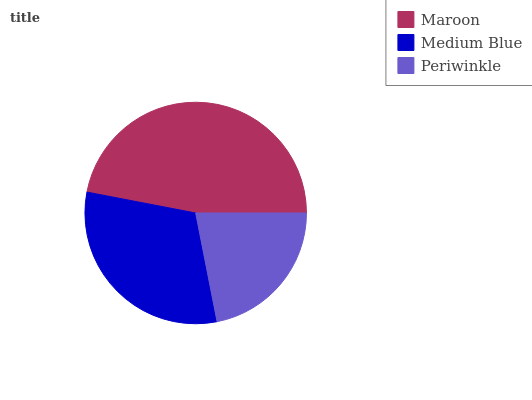Is Periwinkle the minimum?
Answer yes or no. Yes. Is Maroon the maximum?
Answer yes or no. Yes. Is Medium Blue the minimum?
Answer yes or no. No. Is Medium Blue the maximum?
Answer yes or no. No. Is Maroon greater than Medium Blue?
Answer yes or no. Yes. Is Medium Blue less than Maroon?
Answer yes or no. Yes. Is Medium Blue greater than Maroon?
Answer yes or no. No. Is Maroon less than Medium Blue?
Answer yes or no. No. Is Medium Blue the high median?
Answer yes or no. Yes. Is Medium Blue the low median?
Answer yes or no. Yes. Is Periwinkle the high median?
Answer yes or no. No. Is Periwinkle the low median?
Answer yes or no. No. 